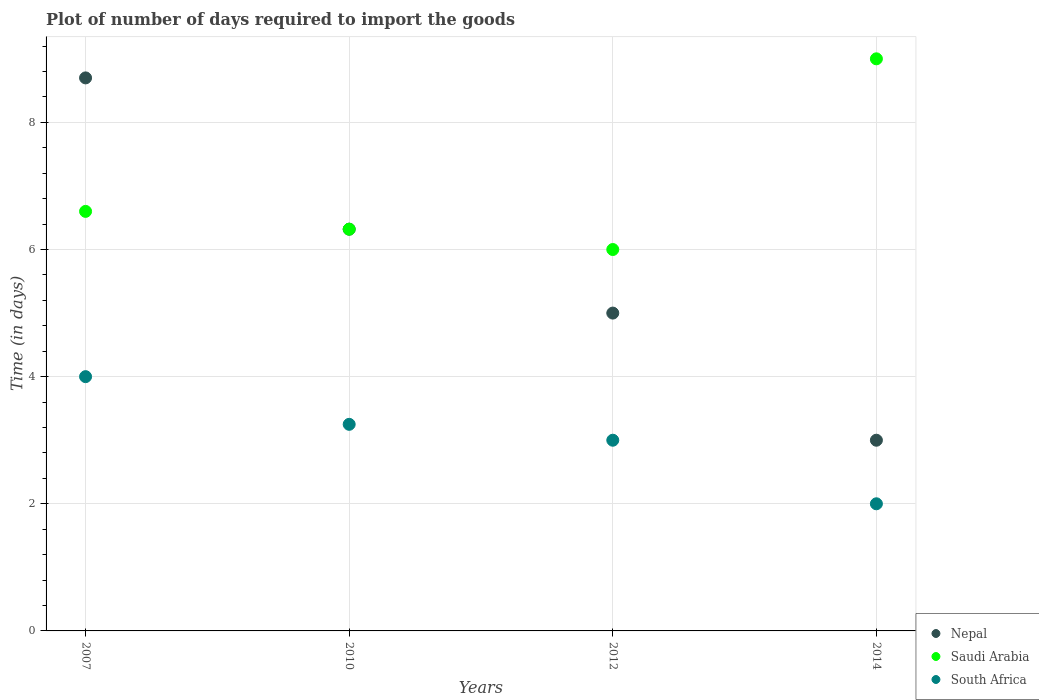How many different coloured dotlines are there?
Make the answer very short. 3. Across all years, what is the maximum time required to import goods in Saudi Arabia?
Offer a very short reply. 9. In which year was the time required to import goods in Nepal maximum?
Keep it short and to the point. 2007. What is the total time required to import goods in South Africa in the graph?
Your answer should be compact. 12.25. What is the difference between the time required to import goods in Nepal in 2007 and that in 2012?
Give a very brief answer. 3.7. What is the difference between the time required to import goods in South Africa in 2014 and the time required to import goods in Saudi Arabia in 2010?
Your answer should be very brief. -4.32. What is the average time required to import goods in Nepal per year?
Provide a short and direct response. 5.75. In the year 2014, what is the difference between the time required to import goods in Saudi Arabia and time required to import goods in South Africa?
Provide a short and direct response. 7. What is the ratio of the time required to import goods in Saudi Arabia in 2007 to that in 2014?
Provide a short and direct response. 0.73. Is the time required to import goods in Saudi Arabia in 2010 less than that in 2014?
Ensure brevity in your answer.  Yes. Is the difference between the time required to import goods in Saudi Arabia in 2010 and 2012 greater than the difference between the time required to import goods in South Africa in 2010 and 2012?
Your response must be concise. Yes. What is the difference between the highest and the second highest time required to import goods in Nepal?
Make the answer very short. 2.38. Is the sum of the time required to import goods in Saudi Arabia in 2010 and 2012 greater than the maximum time required to import goods in Nepal across all years?
Offer a very short reply. Yes. Is it the case that in every year, the sum of the time required to import goods in Saudi Arabia and time required to import goods in South Africa  is greater than the time required to import goods in Nepal?
Ensure brevity in your answer.  Yes. Does the time required to import goods in Saudi Arabia monotonically increase over the years?
Provide a short and direct response. No. Is the time required to import goods in South Africa strictly greater than the time required to import goods in Nepal over the years?
Offer a very short reply. No. How many dotlines are there?
Make the answer very short. 3. How many years are there in the graph?
Give a very brief answer. 4. What is the difference between two consecutive major ticks on the Y-axis?
Give a very brief answer. 2. Does the graph contain grids?
Ensure brevity in your answer.  Yes. Where does the legend appear in the graph?
Give a very brief answer. Bottom right. How are the legend labels stacked?
Your response must be concise. Vertical. What is the title of the graph?
Make the answer very short. Plot of number of days required to import the goods. Does "Israel" appear as one of the legend labels in the graph?
Offer a very short reply. No. What is the label or title of the Y-axis?
Make the answer very short. Time (in days). What is the Time (in days) in Nepal in 2007?
Keep it short and to the point. 8.7. What is the Time (in days) of Nepal in 2010?
Ensure brevity in your answer.  6.32. What is the Time (in days) in Saudi Arabia in 2010?
Provide a short and direct response. 6.32. What is the Time (in days) of South Africa in 2010?
Give a very brief answer. 3.25. What is the Time (in days) in Nepal in 2014?
Your response must be concise. 3. Across all years, what is the maximum Time (in days) of South Africa?
Keep it short and to the point. 4. Across all years, what is the minimum Time (in days) of Nepal?
Offer a very short reply. 3. Across all years, what is the minimum Time (in days) of Saudi Arabia?
Offer a very short reply. 6. Across all years, what is the minimum Time (in days) in South Africa?
Your answer should be compact. 2. What is the total Time (in days) of Nepal in the graph?
Offer a terse response. 23.02. What is the total Time (in days) of Saudi Arabia in the graph?
Offer a very short reply. 27.92. What is the total Time (in days) of South Africa in the graph?
Give a very brief answer. 12.25. What is the difference between the Time (in days) of Nepal in 2007 and that in 2010?
Offer a terse response. 2.38. What is the difference between the Time (in days) of Saudi Arabia in 2007 and that in 2010?
Provide a succinct answer. 0.28. What is the difference between the Time (in days) of South Africa in 2007 and that in 2010?
Give a very brief answer. 0.75. What is the difference between the Time (in days) of Nepal in 2007 and that in 2012?
Provide a short and direct response. 3.7. What is the difference between the Time (in days) in Saudi Arabia in 2007 and that in 2012?
Offer a terse response. 0.6. What is the difference between the Time (in days) in Nepal in 2007 and that in 2014?
Make the answer very short. 5.7. What is the difference between the Time (in days) of Saudi Arabia in 2007 and that in 2014?
Ensure brevity in your answer.  -2.4. What is the difference between the Time (in days) in Nepal in 2010 and that in 2012?
Provide a succinct answer. 1.32. What is the difference between the Time (in days) in Saudi Arabia in 2010 and that in 2012?
Make the answer very short. 0.32. What is the difference between the Time (in days) of Nepal in 2010 and that in 2014?
Ensure brevity in your answer.  3.32. What is the difference between the Time (in days) in Saudi Arabia in 2010 and that in 2014?
Your answer should be very brief. -2.68. What is the difference between the Time (in days) of Nepal in 2012 and that in 2014?
Keep it short and to the point. 2. What is the difference between the Time (in days) of Nepal in 2007 and the Time (in days) of Saudi Arabia in 2010?
Your answer should be very brief. 2.38. What is the difference between the Time (in days) of Nepal in 2007 and the Time (in days) of South Africa in 2010?
Keep it short and to the point. 5.45. What is the difference between the Time (in days) of Saudi Arabia in 2007 and the Time (in days) of South Africa in 2010?
Your answer should be compact. 3.35. What is the difference between the Time (in days) in Nepal in 2007 and the Time (in days) in Saudi Arabia in 2012?
Your answer should be very brief. 2.7. What is the difference between the Time (in days) in Nepal in 2007 and the Time (in days) in South Africa in 2012?
Offer a terse response. 5.7. What is the difference between the Time (in days) of Nepal in 2010 and the Time (in days) of Saudi Arabia in 2012?
Offer a terse response. 0.32. What is the difference between the Time (in days) in Nepal in 2010 and the Time (in days) in South Africa in 2012?
Your answer should be compact. 3.32. What is the difference between the Time (in days) of Saudi Arabia in 2010 and the Time (in days) of South Africa in 2012?
Your answer should be very brief. 3.32. What is the difference between the Time (in days) of Nepal in 2010 and the Time (in days) of Saudi Arabia in 2014?
Provide a succinct answer. -2.68. What is the difference between the Time (in days) of Nepal in 2010 and the Time (in days) of South Africa in 2014?
Keep it short and to the point. 4.32. What is the difference between the Time (in days) in Saudi Arabia in 2010 and the Time (in days) in South Africa in 2014?
Your response must be concise. 4.32. What is the difference between the Time (in days) in Nepal in 2012 and the Time (in days) in South Africa in 2014?
Make the answer very short. 3. What is the average Time (in days) of Nepal per year?
Give a very brief answer. 5.75. What is the average Time (in days) in Saudi Arabia per year?
Your answer should be compact. 6.98. What is the average Time (in days) of South Africa per year?
Give a very brief answer. 3.06. In the year 2007, what is the difference between the Time (in days) in Saudi Arabia and Time (in days) in South Africa?
Offer a terse response. 2.6. In the year 2010, what is the difference between the Time (in days) of Nepal and Time (in days) of South Africa?
Keep it short and to the point. 3.07. In the year 2010, what is the difference between the Time (in days) in Saudi Arabia and Time (in days) in South Africa?
Provide a short and direct response. 3.07. In the year 2014, what is the difference between the Time (in days) of Nepal and Time (in days) of Saudi Arabia?
Your answer should be compact. -6. In the year 2014, what is the difference between the Time (in days) of Saudi Arabia and Time (in days) of South Africa?
Your answer should be very brief. 7. What is the ratio of the Time (in days) of Nepal in 2007 to that in 2010?
Your response must be concise. 1.38. What is the ratio of the Time (in days) of Saudi Arabia in 2007 to that in 2010?
Ensure brevity in your answer.  1.04. What is the ratio of the Time (in days) in South Africa in 2007 to that in 2010?
Offer a terse response. 1.23. What is the ratio of the Time (in days) of Nepal in 2007 to that in 2012?
Ensure brevity in your answer.  1.74. What is the ratio of the Time (in days) of Saudi Arabia in 2007 to that in 2012?
Give a very brief answer. 1.1. What is the ratio of the Time (in days) in Nepal in 2007 to that in 2014?
Your answer should be very brief. 2.9. What is the ratio of the Time (in days) in Saudi Arabia in 2007 to that in 2014?
Give a very brief answer. 0.73. What is the ratio of the Time (in days) of Nepal in 2010 to that in 2012?
Your answer should be compact. 1.26. What is the ratio of the Time (in days) in Saudi Arabia in 2010 to that in 2012?
Give a very brief answer. 1.05. What is the ratio of the Time (in days) in South Africa in 2010 to that in 2012?
Offer a very short reply. 1.08. What is the ratio of the Time (in days) of Nepal in 2010 to that in 2014?
Give a very brief answer. 2.11. What is the ratio of the Time (in days) of Saudi Arabia in 2010 to that in 2014?
Your answer should be compact. 0.7. What is the ratio of the Time (in days) of South Africa in 2010 to that in 2014?
Provide a short and direct response. 1.62. What is the difference between the highest and the second highest Time (in days) in Nepal?
Provide a short and direct response. 2.38. What is the difference between the highest and the second highest Time (in days) of South Africa?
Keep it short and to the point. 0.75. What is the difference between the highest and the lowest Time (in days) of Nepal?
Ensure brevity in your answer.  5.7. What is the difference between the highest and the lowest Time (in days) of South Africa?
Offer a terse response. 2. 